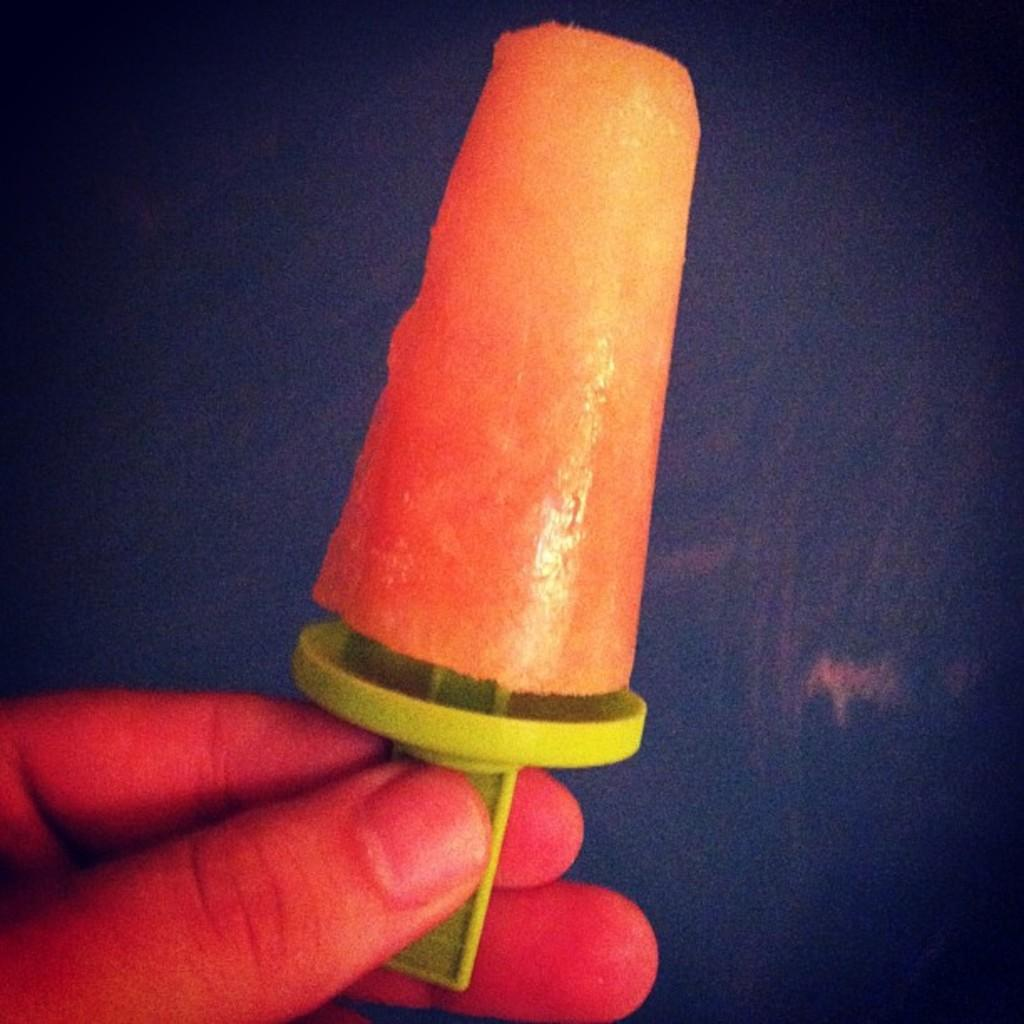What can be seen in the person's hand in the image? There is an object in the person's hand in the image. Can you describe the background details be observed in the image? Yes, the background of the image is dark. What type of cracker is being held by the person's hand in the image? There is no cracker present in the image; only a person's hand and an object in it are visible. Can you see any branches in the image? There are no branches visible in the image; the background is dark, and only the person's hand and the object in it are present. 